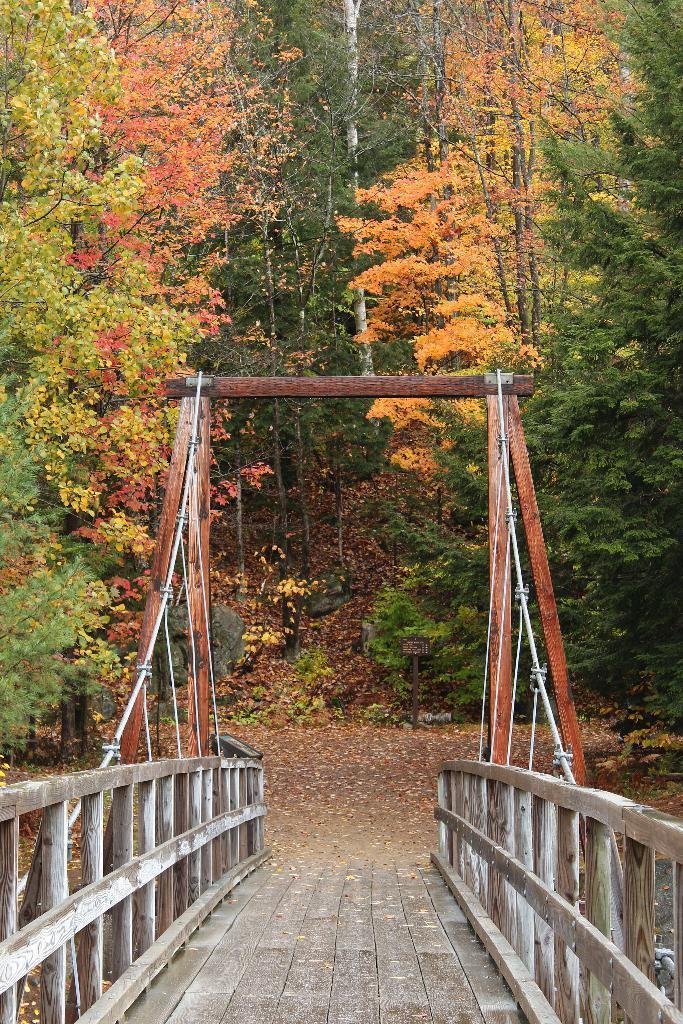Describe this image in one or two sentences. In this image we can see the wooden bridge. And we can see one wooden pole near the bridge. And we can see the trees. And we can see the rocks. And we can see the land. 